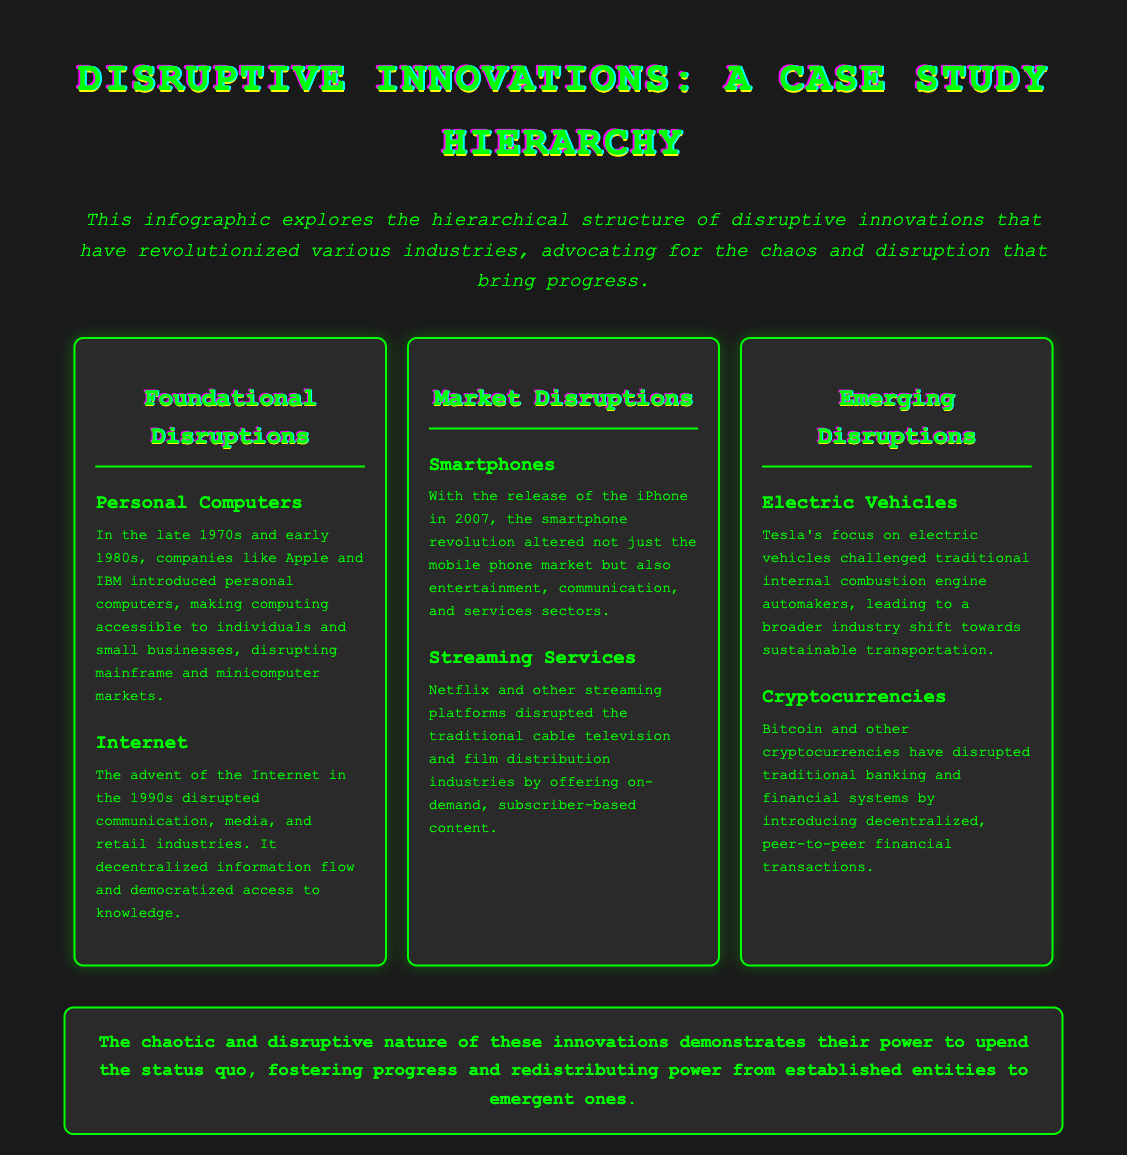what are the two foundational disruptions listed? The foundational disruptions listed include Personal Computers and Internet, which represent the foundational technological shifts in the document.
Answer: Personal Computers, Internet which smartphone is mentioned as a revolutionary device? The iPhone is specifically mentioned as the smartphone that revolutionized the market upon its release in 2007.
Answer: iPhone what industry did streaming services disrupt? Streaming services disrupted the traditional cable television and film distribution industries, highlighting their impact on media consumption.
Answer: cable television and film distribution what is the primary focus of Tesla according to the document? Tesla's primary focus is on electric vehicles, showcasing a shift in the automotive industry toward sustainability.
Answer: electric vehicles what type of financial transactions do cryptocurrencies introduce? Cryptocurrencies introduce decentralized, peer-to-peer financial transactions, altering traditional banking systems.
Answer: peer-to-peer financial transactions how many levels are there in the hierarchy of disruptions? There are three levels in the hierarchy of disruptions, representing different stages of technological advancement.
Answer: three which level includes Electric Vehicles and Cryptocurrencies? Electric Vehicles and Cryptocurrencies are categorized under the Emerging Disruptions level, signifying their recent influence on markets.
Answer: Emerging Disruptions what does the conclusion emphasize about disruptive innovations? The conclusion emphasizes the chaotic and disruptive nature of innovations, highlighting their potential to foster progress and redistribute power.
Answer: power to foster progress 